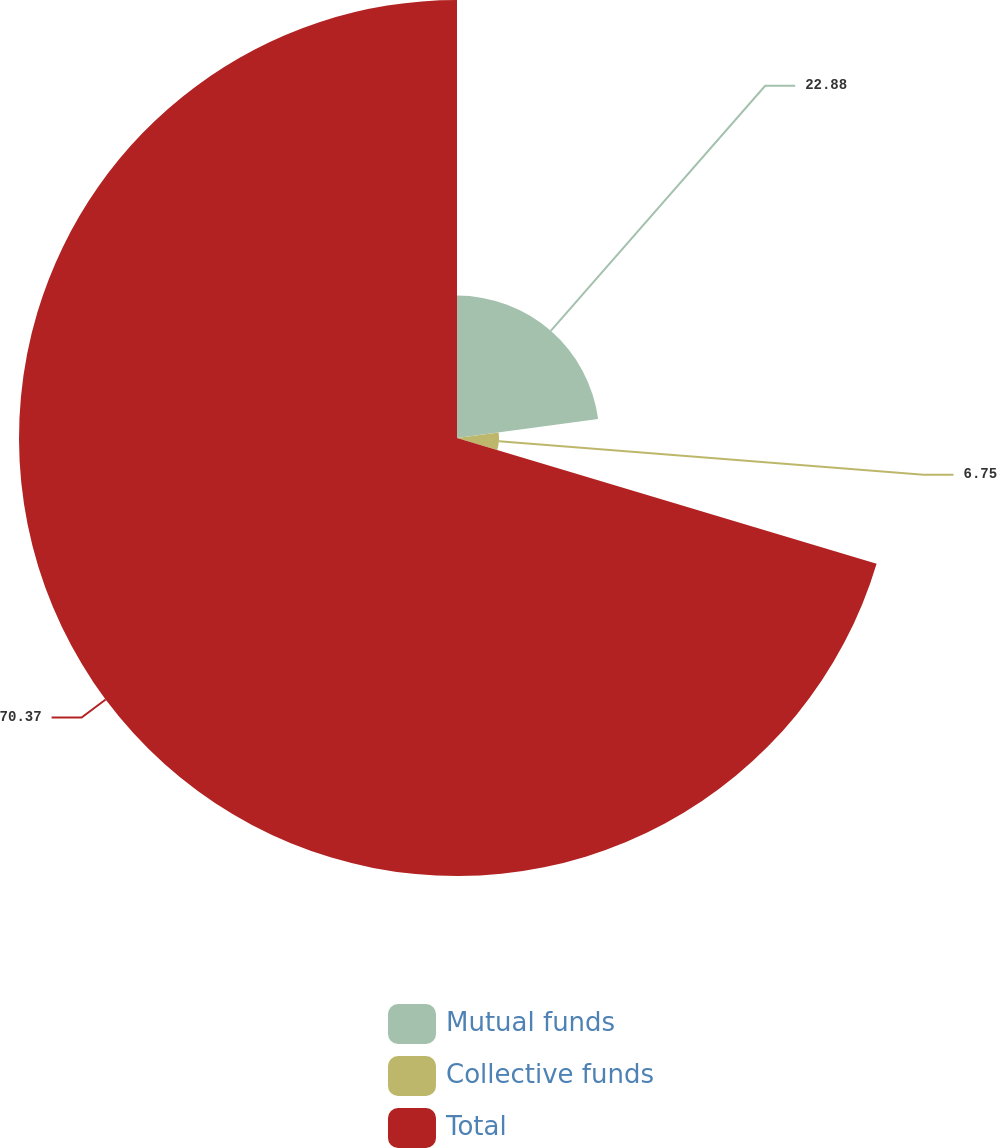Convert chart. <chart><loc_0><loc_0><loc_500><loc_500><pie_chart><fcel>Mutual funds<fcel>Collective funds<fcel>Total<nl><fcel>22.88%<fcel>6.75%<fcel>70.37%<nl></chart> 